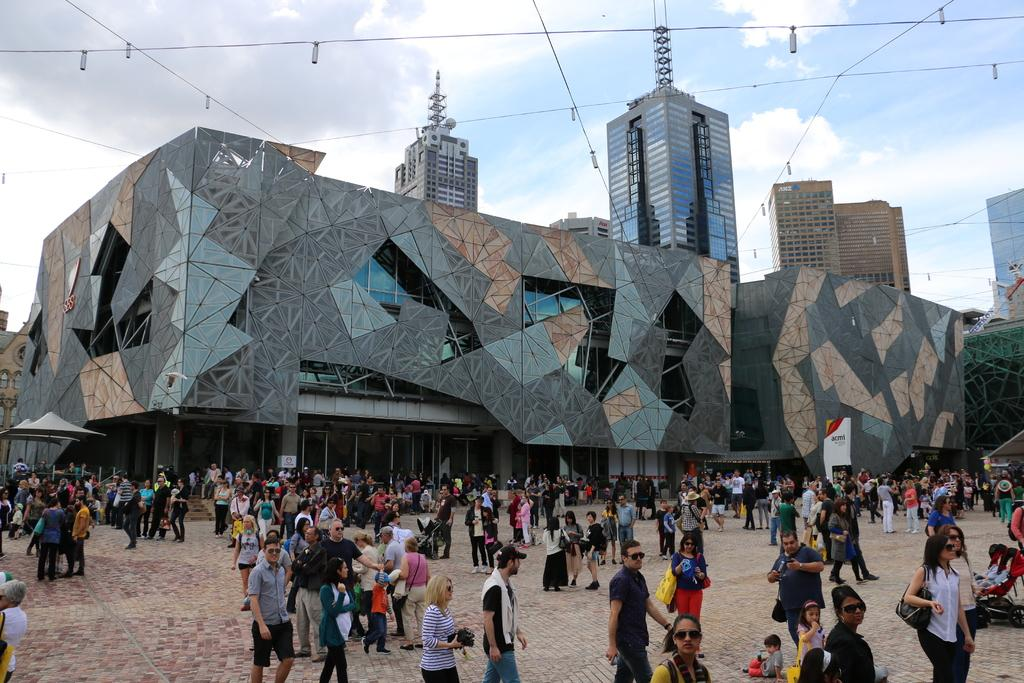What is happening at the bottom of the image? There is a crowd on a path at the bottom of the image. What can be seen in the distance in the image? There are buildings in the background of the image. Are there any specific structures or objects visible in the background? Yes, a crane and wires are visible in the background of the image. How would you describe the weather in the image? The sky is cloudy in the background of the image. Where is the maid in the image? There is no maid present in the image. What type of plants can be seen growing near the crowd? There is no mention of plants in the image; the focus is on the crowd, buildings, and background objects. 